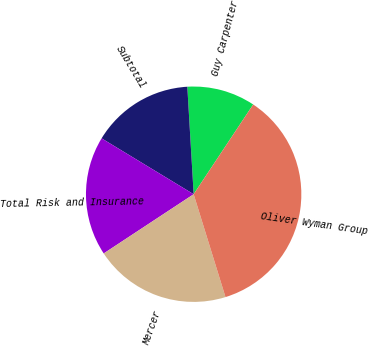<chart> <loc_0><loc_0><loc_500><loc_500><pie_chart><fcel>Guy Carpenter<fcel>Subtotal<fcel>Total Risk and Insurance<fcel>Mercer<fcel>Oliver Wyman Group<nl><fcel>10.26%<fcel>15.38%<fcel>17.95%<fcel>20.51%<fcel>35.9%<nl></chart> 